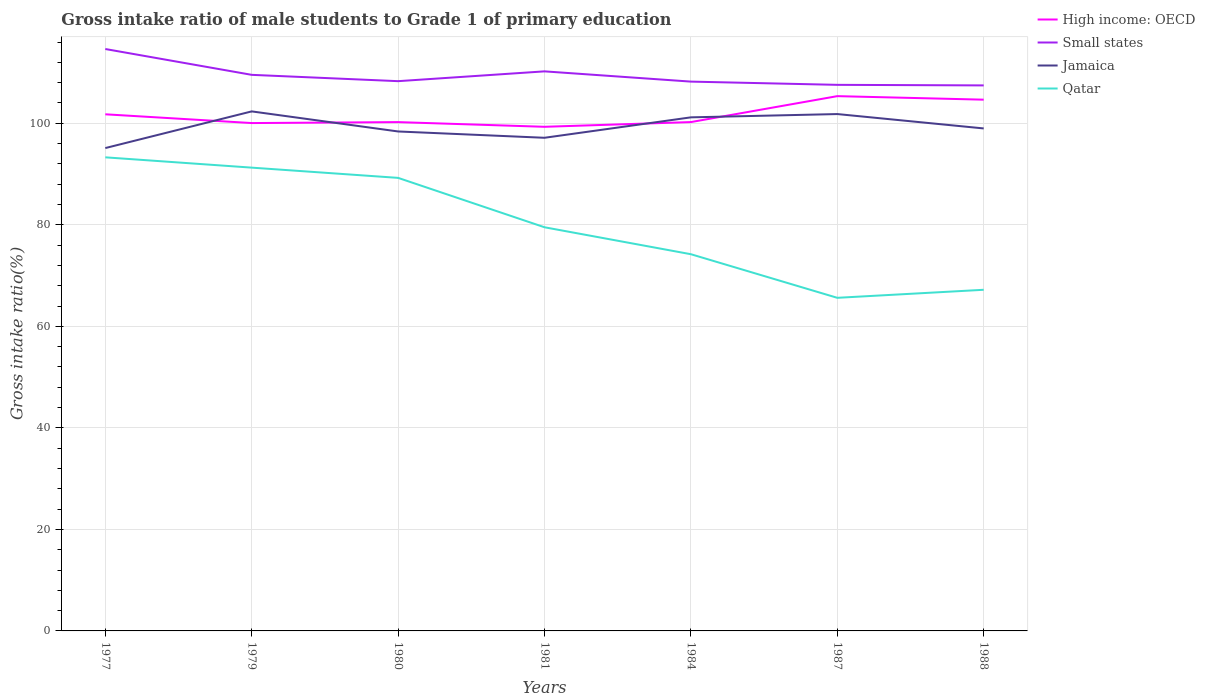How many different coloured lines are there?
Your answer should be compact. 4. Does the line corresponding to Qatar intersect with the line corresponding to High income: OECD?
Provide a short and direct response. No. Is the number of lines equal to the number of legend labels?
Make the answer very short. Yes. Across all years, what is the maximum gross intake ratio in High income: OECD?
Provide a succinct answer. 99.3. What is the total gross intake ratio in Jamaica in the graph?
Your response must be concise. -6.7. What is the difference between the highest and the second highest gross intake ratio in Jamaica?
Offer a very short reply. 7.22. What is the difference between the highest and the lowest gross intake ratio in Small states?
Your response must be concise. 3. How many years are there in the graph?
Offer a terse response. 7. What is the difference between two consecutive major ticks on the Y-axis?
Provide a short and direct response. 20. Are the values on the major ticks of Y-axis written in scientific E-notation?
Your answer should be very brief. No. Does the graph contain any zero values?
Offer a terse response. No. What is the title of the graph?
Provide a short and direct response. Gross intake ratio of male students to Grade 1 of primary education. Does "New Zealand" appear as one of the legend labels in the graph?
Offer a terse response. No. What is the label or title of the Y-axis?
Ensure brevity in your answer.  Gross intake ratio(%). What is the Gross intake ratio(%) in High income: OECD in 1977?
Offer a terse response. 101.77. What is the Gross intake ratio(%) in Small states in 1977?
Offer a terse response. 114.63. What is the Gross intake ratio(%) of Jamaica in 1977?
Give a very brief answer. 95.12. What is the Gross intake ratio(%) in Qatar in 1977?
Provide a succinct answer. 93.29. What is the Gross intake ratio(%) of High income: OECD in 1979?
Your answer should be compact. 100.04. What is the Gross intake ratio(%) in Small states in 1979?
Offer a very short reply. 109.54. What is the Gross intake ratio(%) in Jamaica in 1979?
Provide a succinct answer. 102.34. What is the Gross intake ratio(%) in Qatar in 1979?
Provide a short and direct response. 91.26. What is the Gross intake ratio(%) in High income: OECD in 1980?
Your answer should be compact. 100.23. What is the Gross intake ratio(%) in Small states in 1980?
Offer a very short reply. 108.29. What is the Gross intake ratio(%) of Jamaica in 1980?
Keep it short and to the point. 98.38. What is the Gross intake ratio(%) of Qatar in 1980?
Offer a very short reply. 89.24. What is the Gross intake ratio(%) in High income: OECD in 1981?
Provide a short and direct response. 99.3. What is the Gross intake ratio(%) in Small states in 1981?
Make the answer very short. 110.22. What is the Gross intake ratio(%) in Jamaica in 1981?
Keep it short and to the point. 97.14. What is the Gross intake ratio(%) of Qatar in 1981?
Give a very brief answer. 79.51. What is the Gross intake ratio(%) in High income: OECD in 1984?
Offer a very short reply. 100.23. What is the Gross intake ratio(%) in Small states in 1984?
Offer a very short reply. 108.2. What is the Gross intake ratio(%) of Jamaica in 1984?
Your answer should be compact. 101.17. What is the Gross intake ratio(%) of Qatar in 1984?
Ensure brevity in your answer.  74.2. What is the Gross intake ratio(%) in High income: OECD in 1987?
Keep it short and to the point. 105.34. What is the Gross intake ratio(%) of Small states in 1987?
Your response must be concise. 107.57. What is the Gross intake ratio(%) of Jamaica in 1987?
Provide a succinct answer. 101.81. What is the Gross intake ratio(%) of Qatar in 1987?
Provide a succinct answer. 65.62. What is the Gross intake ratio(%) of High income: OECD in 1988?
Your response must be concise. 104.65. What is the Gross intake ratio(%) in Small states in 1988?
Ensure brevity in your answer.  107.46. What is the Gross intake ratio(%) in Jamaica in 1988?
Your response must be concise. 98.98. What is the Gross intake ratio(%) in Qatar in 1988?
Ensure brevity in your answer.  67.2. Across all years, what is the maximum Gross intake ratio(%) of High income: OECD?
Provide a short and direct response. 105.34. Across all years, what is the maximum Gross intake ratio(%) of Small states?
Provide a succinct answer. 114.63. Across all years, what is the maximum Gross intake ratio(%) in Jamaica?
Offer a terse response. 102.34. Across all years, what is the maximum Gross intake ratio(%) of Qatar?
Your answer should be compact. 93.29. Across all years, what is the minimum Gross intake ratio(%) in High income: OECD?
Provide a short and direct response. 99.3. Across all years, what is the minimum Gross intake ratio(%) in Small states?
Your response must be concise. 107.46. Across all years, what is the minimum Gross intake ratio(%) in Jamaica?
Give a very brief answer. 95.12. Across all years, what is the minimum Gross intake ratio(%) in Qatar?
Your response must be concise. 65.62. What is the total Gross intake ratio(%) of High income: OECD in the graph?
Offer a terse response. 711.56. What is the total Gross intake ratio(%) in Small states in the graph?
Your answer should be compact. 765.91. What is the total Gross intake ratio(%) in Jamaica in the graph?
Your answer should be compact. 694.94. What is the total Gross intake ratio(%) in Qatar in the graph?
Make the answer very short. 560.32. What is the difference between the Gross intake ratio(%) of High income: OECD in 1977 and that in 1979?
Offer a very short reply. 1.73. What is the difference between the Gross intake ratio(%) in Small states in 1977 and that in 1979?
Give a very brief answer. 5.09. What is the difference between the Gross intake ratio(%) of Jamaica in 1977 and that in 1979?
Ensure brevity in your answer.  -7.22. What is the difference between the Gross intake ratio(%) of Qatar in 1977 and that in 1979?
Your answer should be compact. 2.03. What is the difference between the Gross intake ratio(%) in High income: OECD in 1977 and that in 1980?
Your answer should be very brief. 1.54. What is the difference between the Gross intake ratio(%) of Small states in 1977 and that in 1980?
Give a very brief answer. 6.33. What is the difference between the Gross intake ratio(%) in Jamaica in 1977 and that in 1980?
Offer a terse response. -3.27. What is the difference between the Gross intake ratio(%) of Qatar in 1977 and that in 1980?
Your answer should be very brief. 4.05. What is the difference between the Gross intake ratio(%) of High income: OECD in 1977 and that in 1981?
Your answer should be very brief. 2.46. What is the difference between the Gross intake ratio(%) of Small states in 1977 and that in 1981?
Ensure brevity in your answer.  4.4. What is the difference between the Gross intake ratio(%) in Jamaica in 1977 and that in 1981?
Give a very brief answer. -2.03. What is the difference between the Gross intake ratio(%) in Qatar in 1977 and that in 1981?
Make the answer very short. 13.78. What is the difference between the Gross intake ratio(%) of High income: OECD in 1977 and that in 1984?
Make the answer very short. 1.53. What is the difference between the Gross intake ratio(%) of Small states in 1977 and that in 1984?
Your answer should be compact. 6.42. What is the difference between the Gross intake ratio(%) of Jamaica in 1977 and that in 1984?
Make the answer very short. -6.05. What is the difference between the Gross intake ratio(%) in Qatar in 1977 and that in 1984?
Ensure brevity in your answer.  19.09. What is the difference between the Gross intake ratio(%) in High income: OECD in 1977 and that in 1987?
Provide a succinct answer. -3.58. What is the difference between the Gross intake ratio(%) in Small states in 1977 and that in 1987?
Ensure brevity in your answer.  7.06. What is the difference between the Gross intake ratio(%) of Jamaica in 1977 and that in 1987?
Your answer should be very brief. -6.7. What is the difference between the Gross intake ratio(%) of Qatar in 1977 and that in 1987?
Give a very brief answer. 27.67. What is the difference between the Gross intake ratio(%) of High income: OECD in 1977 and that in 1988?
Your answer should be compact. -2.88. What is the difference between the Gross intake ratio(%) in Small states in 1977 and that in 1988?
Make the answer very short. 7.17. What is the difference between the Gross intake ratio(%) in Jamaica in 1977 and that in 1988?
Provide a short and direct response. -3.87. What is the difference between the Gross intake ratio(%) in Qatar in 1977 and that in 1988?
Offer a very short reply. 26.09. What is the difference between the Gross intake ratio(%) of High income: OECD in 1979 and that in 1980?
Offer a very short reply. -0.19. What is the difference between the Gross intake ratio(%) in Small states in 1979 and that in 1980?
Your answer should be compact. 1.24. What is the difference between the Gross intake ratio(%) of Jamaica in 1979 and that in 1980?
Offer a very short reply. 3.95. What is the difference between the Gross intake ratio(%) of Qatar in 1979 and that in 1980?
Make the answer very short. 2.02. What is the difference between the Gross intake ratio(%) in High income: OECD in 1979 and that in 1981?
Make the answer very short. 0.74. What is the difference between the Gross intake ratio(%) of Small states in 1979 and that in 1981?
Your answer should be very brief. -0.69. What is the difference between the Gross intake ratio(%) of Jamaica in 1979 and that in 1981?
Your response must be concise. 5.2. What is the difference between the Gross intake ratio(%) in Qatar in 1979 and that in 1981?
Your response must be concise. 11.75. What is the difference between the Gross intake ratio(%) of High income: OECD in 1979 and that in 1984?
Offer a very short reply. -0.19. What is the difference between the Gross intake ratio(%) of Small states in 1979 and that in 1984?
Make the answer very short. 1.33. What is the difference between the Gross intake ratio(%) of Jamaica in 1979 and that in 1984?
Provide a succinct answer. 1.17. What is the difference between the Gross intake ratio(%) in Qatar in 1979 and that in 1984?
Provide a succinct answer. 17.06. What is the difference between the Gross intake ratio(%) of High income: OECD in 1979 and that in 1987?
Offer a terse response. -5.3. What is the difference between the Gross intake ratio(%) of Small states in 1979 and that in 1987?
Ensure brevity in your answer.  1.97. What is the difference between the Gross intake ratio(%) in Jamaica in 1979 and that in 1987?
Your answer should be very brief. 0.52. What is the difference between the Gross intake ratio(%) in Qatar in 1979 and that in 1987?
Ensure brevity in your answer.  25.64. What is the difference between the Gross intake ratio(%) in High income: OECD in 1979 and that in 1988?
Give a very brief answer. -4.61. What is the difference between the Gross intake ratio(%) of Small states in 1979 and that in 1988?
Provide a short and direct response. 2.08. What is the difference between the Gross intake ratio(%) of Jamaica in 1979 and that in 1988?
Keep it short and to the point. 3.36. What is the difference between the Gross intake ratio(%) of Qatar in 1979 and that in 1988?
Give a very brief answer. 24.06. What is the difference between the Gross intake ratio(%) of High income: OECD in 1980 and that in 1981?
Give a very brief answer. 0.92. What is the difference between the Gross intake ratio(%) in Small states in 1980 and that in 1981?
Your answer should be very brief. -1.93. What is the difference between the Gross intake ratio(%) of Jamaica in 1980 and that in 1981?
Your answer should be very brief. 1.24. What is the difference between the Gross intake ratio(%) of Qatar in 1980 and that in 1981?
Provide a succinct answer. 9.73. What is the difference between the Gross intake ratio(%) of High income: OECD in 1980 and that in 1984?
Provide a succinct answer. -0.01. What is the difference between the Gross intake ratio(%) of Small states in 1980 and that in 1984?
Provide a short and direct response. 0.09. What is the difference between the Gross intake ratio(%) in Jamaica in 1980 and that in 1984?
Your answer should be compact. -2.78. What is the difference between the Gross intake ratio(%) of Qatar in 1980 and that in 1984?
Ensure brevity in your answer.  15.04. What is the difference between the Gross intake ratio(%) of High income: OECD in 1980 and that in 1987?
Give a very brief answer. -5.11. What is the difference between the Gross intake ratio(%) in Small states in 1980 and that in 1987?
Keep it short and to the point. 0.72. What is the difference between the Gross intake ratio(%) of Jamaica in 1980 and that in 1987?
Your answer should be compact. -3.43. What is the difference between the Gross intake ratio(%) in Qatar in 1980 and that in 1987?
Make the answer very short. 23.63. What is the difference between the Gross intake ratio(%) of High income: OECD in 1980 and that in 1988?
Provide a short and direct response. -4.42. What is the difference between the Gross intake ratio(%) in Small states in 1980 and that in 1988?
Make the answer very short. 0.84. What is the difference between the Gross intake ratio(%) of Jamaica in 1980 and that in 1988?
Your answer should be very brief. -0.6. What is the difference between the Gross intake ratio(%) in Qatar in 1980 and that in 1988?
Your response must be concise. 22.04. What is the difference between the Gross intake ratio(%) of High income: OECD in 1981 and that in 1984?
Your answer should be compact. -0.93. What is the difference between the Gross intake ratio(%) in Small states in 1981 and that in 1984?
Your answer should be compact. 2.02. What is the difference between the Gross intake ratio(%) in Jamaica in 1981 and that in 1984?
Your answer should be very brief. -4.03. What is the difference between the Gross intake ratio(%) of Qatar in 1981 and that in 1984?
Offer a very short reply. 5.31. What is the difference between the Gross intake ratio(%) in High income: OECD in 1981 and that in 1987?
Your response must be concise. -6.04. What is the difference between the Gross intake ratio(%) in Small states in 1981 and that in 1987?
Make the answer very short. 2.66. What is the difference between the Gross intake ratio(%) of Jamaica in 1981 and that in 1987?
Give a very brief answer. -4.67. What is the difference between the Gross intake ratio(%) in Qatar in 1981 and that in 1987?
Provide a short and direct response. 13.9. What is the difference between the Gross intake ratio(%) of High income: OECD in 1981 and that in 1988?
Ensure brevity in your answer.  -5.34. What is the difference between the Gross intake ratio(%) of Small states in 1981 and that in 1988?
Make the answer very short. 2.77. What is the difference between the Gross intake ratio(%) in Jamaica in 1981 and that in 1988?
Ensure brevity in your answer.  -1.84. What is the difference between the Gross intake ratio(%) in Qatar in 1981 and that in 1988?
Make the answer very short. 12.31. What is the difference between the Gross intake ratio(%) of High income: OECD in 1984 and that in 1987?
Your answer should be compact. -5.11. What is the difference between the Gross intake ratio(%) in Small states in 1984 and that in 1987?
Ensure brevity in your answer.  0.64. What is the difference between the Gross intake ratio(%) of Jamaica in 1984 and that in 1987?
Your response must be concise. -0.65. What is the difference between the Gross intake ratio(%) of Qatar in 1984 and that in 1987?
Your response must be concise. 8.59. What is the difference between the Gross intake ratio(%) in High income: OECD in 1984 and that in 1988?
Give a very brief answer. -4.41. What is the difference between the Gross intake ratio(%) in Small states in 1984 and that in 1988?
Ensure brevity in your answer.  0.75. What is the difference between the Gross intake ratio(%) in Jamaica in 1984 and that in 1988?
Provide a succinct answer. 2.19. What is the difference between the Gross intake ratio(%) in Qatar in 1984 and that in 1988?
Ensure brevity in your answer.  7. What is the difference between the Gross intake ratio(%) of High income: OECD in 1987 and that in 1988?
Give a very brief answer. 0.7. What is the difference between the Gross intake ratio(%) in Small states in 1987 and that in 1988?
Ensure brevity in your answer.  0.11. What is the difference between the Gross intake ratio(%) of Jamaica in 1987 and that in 1988?
Provide a short and direct response. 2.83. What is the difference between the Gross intake ratio(%) of Qatar in 1987 and that in 1988?
Your answer should be compact. -1.58. What is the difference between the Gross intake ratio(%) of High income: OECD in 1977 and the Gross intake ratio(%) of Small states in 1979?
Your answer should be compact. -7.77. What is the difference between the Gross intake ratio(%) of High income: OECD in 1977 and the Gross intake ratio(%) of Jamaica in 1979?
Ensure brevity in your answer.  -0.57. What is the difference between the Gross intake ratio(%) in High income: OECD in 1977 and the Gross intake ratio(%) in Qatar in 1979?
Your answer should be very brief. 10.51. What is the difference between the Gross intake ratio(%) in Small states in 1977 and the Gross intake ratio(%) in Jamaica in 1979?
Keep it short and to the point. 12.29. What is the difference between the Gross intake ratio(%) of Small states in 1977 and the Gross intake ratio(%) of Qatar in 1979?
Your response must be concise. 23.37. What is the difference between the Gross intake ratio(%) in Jamaica in 1977 and the Gross intake ratio(%) in Qatar in 1979?
Give a very brief answer. 3.86. What is the difference between the Gross intake ratio(%) in High income: OECD in 1977 and the Gross intake ratio(%) in Small states in 1980?
Your answer should be very brief. -6.53. What is the difference between the Gross intake ratio(%) of High income: OECD in 1977 and the Gross intake ratio(%) of Jamaica in 1980?
Provide a short and direct response. 3.38. What is the difference between the Gross intake ratio(%) in High income: OECD in 1977 and the Gross intake ratio(%) in Qatar in 1980?
Give a very brief answer. 12.52. What is the difference between the Gross intake ratio(%) of Small states in 1977 and the Gross intake ratio(%) of Jamaica in 1980?
Offer a terse response. 16.24. What is the difference between the Gross intake ratio(%) of Small states in 1977 and the Gross intake ratio(%) of Qatar in 1980?
Your response must be concise. 25.38. What is the difference between the Gross intake ratio(%) of Jamaica in 1977 and the Gross intake ratio(%) of Qatar in 1980?
Make the answer very short. 5.87. What is the difference between the Gross intake ratio(%) of High income: OECD in 1977 and the Gross intake ratio(%) of Small states in 1981?
Give a very brief answer. -8.46. What is the difference between the Gross intake ratio(%) in High income: OECD in 1977 and the Gross intake ratio(%) in Jamaica in 1981?
Provide a succinct answer. 4.63. What is the difference between the Gross intake ratio(%) of High income: OECD in 1977 and the Gross intake ratio(%) of Qatar in 1981?
Provide a short and direct response. 22.25. What is the difference between the Gross intake ratio(%) of Small states in 1977 and the Gross intake ratio(%) of Jamaica in 1981?
Provide a short and direct response. 17.48. What is the difference between the Gross intake ratio(%) in Small states in 1977 and the Gross intake ratio(%) in Qatar in 1981?
Provide a succinct answer. 35.11. What is the difference between the Gross intake ratio(%) of Jamaica in 1977 and the Gross intake ratio(%) of Qatar in 1981?
Keep it short and to the point. 15.6. What is the difference between the Gross intake ratio(%) in High income: OECD in 1977 and the Gross intake ratio(%) in Small states in 1984?
Provide a succinct answer. -6.44. What is the difference between the Gross intake ratio(%) in High income: OECD in 1977 and the Gross intake ratio(%) in Jamaica in 1984?
Keep it short and to the point. 0.6. What is the difference between the Gross intake ratio(%) in High income: OECD in 1977 and the Gross intake ratio(%) in Qatar in 1984?
Offer a very short reply. 27.56. What is the difference between the Gross intake ratio(%) of Small states in 1977 and the Gross intake ratio(%) of Jamaica in 1984?
Offer a terse response. 13.46. What is the difference between the Gross intake ratio(%) in Small states in 1977 and the Gross intake ratio(%) in Qatar in 1984?
Ensure brevity in your answer.  40.42. What is the difference between the Gross intake ratio(%) of Jamaica in 1977 and the Gross intake ratio(%) of Qatar in 1984?
Offer a very short reply. 20.91. What is the difference between the Gross intake ratio(%) of High income: OECD in 1977 and the Gross intake ratio(%) of Small states in 1987?
Provide a short and direct response. -5.8. What is the difference between the Gross intake ratio(%) in High income: OECD in 1977 and the Gross intake ratio(%) in Jamaica in 1987?
Give a very brief answer. -0.05. What is the difference between the Gross intake ratio(%) of High income: OECD in 1977 and the Gross intake ratio(%) of Qatar in 1987?
Your response must be concise. 36.15. What is the difference between the Gross intake ratio(%) of Small states in 1977 and the Gross intake ratio(%) of Jamaica in 1987?
Make the answer very short. 12.81. What is the difference between the Gross intake ratio(%) of Small states in 1977 and the Gross intake ratio(%) of Qatar in 1987?
Your answer should be compact. 49.01. What is the difference between the Gross intake ratio(%) of Jamaica in 1977 and the Gross intake ratio(%) of Qatar in 1987?
Ensure brevity in your answer.  29.5. What is the difference between the Gross intake ratio(%) in High income: OECD in 1977 and the Gross intake ratio(%) in Small states in 1988?
Provide a short and direct response. -5.69. What is the difference between the Gross intake ratio(%) in High income: OECD in 1977 and the Gross intake ratio(%) in Jamaica in 1988?
Your answer should be very brief. 2.79. What is the difference between the Gross intake ratio(%) in High income: OECD in 1977 and the Gross intake ratio(%) in Qatar in 1988?
Ensure brevity in your answer.  34.57. What is the difference between the Gross intake ratio(%) of Small states in 1977 and the Gross intake ratio(%) of Jamaica in 1988?
Keep it short and to the point. 15.64. What is the difference between the Gross intake ratio(%) of Small states in 1977 and the Gross intake ratio(%) of Qatar in 1988?
Provide a succinct answer. 47.43. What is the difference between the Gross intake ratio(%) of Jamaica in 1977 and the Gross intake ratio(%) of Qatar in 1988?
Provide a succinct answer. 27.92. What is the difference between the Gross intake ratio(%) in High income: OECD in 1979 and the Gross intake ratio(%) in Small states in 1980?
Your response must be concise. -8.25. What is the difference between the Gross intake ratio(%) of High income: OECD in 1979 and the Gross intake ratio(%) of Jamaica in 1980?
Make the answer very short. 1.66. What is the difference between the Gross intake ratio(%) of High income: OECD in 1979 and the Gross intake ratio(%) of Qatar in 1980?
Offer a terse response. 10.8. What is the difference between the Gross intake ratio(%) of Small states in 1979 and the Gross intake ratio(%) of Jamaica in 1980?
Provide a short and direct response. 11.15. What is the difference between the Gross intake ratio(%) of Small states in 1979 and the Gross intake ratio(%) of Qatar in 1980?
Offer a terse response. 20.29. What is the difference between the Gross intake ratio(%) in Jamaica in 1979 and the Gross intake ratio(%) in Qatar in 1980?
Ensure brevity in your answer.  13.09. What is the difference between the Gross intake ratio(%) in High income: OECD in 1979 and the Gross intake ratio(%) in Small states in 1981?
Your response must be concise. -10.18. What is the difference between the Gross intake ratio(%) of High income: OECD in 1979 and the Gross intake ratio(%) of Jamaica in 1981?
Your answer should be compact. 2.9. What is the difference between the Gross intake ratio(%) of High income: OECD in 1979 and the Gross intake ratio(%) of Qatar in 1981?
Offer a terse response. 20.53. What is the difference between the Gross intake ratio(%) in Small states in 1979 and the Gross intake ratio(%) in Jamaica in 1981?
Ensure brevity in your answer.  12.4. What is the difference between the Gross intake ratio(%) of Small states in 1979 and the Gross intake ratio(%) of Qatar in 1981?
Make the answer very short. 30.02. What is the difference between the Gross intake ratio(%) of Jamaica in 1979 and the Gross intake ratio(%) of Qatar in 1981?
Give a very brief answer. 22.82. What is the difference between the Gross intake ratio(%) of High income: OECD in 1979 and the Gross intake ratio(%) of Small states in 1984?
Your answer should be very brief. -8.16. What is the difference between the Gross intake ratio(%) in High income: OECD in 1979 and the Gross intake ratio(%) in Jamaica in 1984?
Provide a succinct answer. -1.13. What is the difference between the Gross intake ratio(%) of High income: OECD in 1979 and the Gross intake ratio(%) of Qatar in 1984?
Ensure brevity in your answer.  25.84. What is the difference between the Gross intake ratio(%) in Small states in 1979 and the Gross intake ratio(%) in Jamaica in 1984?
Give a very brief answer. 8.37. What is the difference between the Gross intake ratio(%) of Small states in 1979 and the Gross intake ratio(%) of Qatar in 1984?
Your answer should be compact. 35.33. What is the difference between the Gross intake ratio(%) of Jamaica in 1979 and the Gross intake ratio(%) of Qatar in 1984?
Keep it short and to the point. 28.13. What is the difference between the Gross intake ratio(%) in High income: OECD in 1979 and the Gross intake ratio(%) in Small states in 1987?
Ensure brevity in your answer.  -7.53. What is the difference between the Gross intake ratio(%) in High income: OECD in 1979 and the Gross intake ratio(%) in Jamaica in 1987?
Ensure brevity in your answer.  -1.77. What is the difference between the Gross intake ratio(%) of High income: OECD in 1979 and the Gross intake ratio(%) of Qatar in 1987?
Your answer should be compact. 34.42. What is the difference between the Gross intake ratio(%) in Small states in 1979 and the Gross intake ratio(%) in Jamaica in 1987?
Ensure brevity in your answer.  7.72. What is the difference between the Gross intake ratio(%) in Small states in 1979 and the Gross intake ratio(%) in Qatar in 1987?
Provide a short and direct response. 43.92. What is the difference between the Gross intake ratio(%) of Jamaica in 1979 and the Gross intake ratio(%) of Qatar in 1987?
Your answer should be compact. 36.72. What is the difference between the Gross intake ratio(%) in High income: OECD in 1979 and the Gross intake ratio(%) in Small states in 1988?
Your response must be concise. -7.42. What is the difference between the Gross intake ratio(%) in High income: OECD in 1979 and the Gross intake ratio(%) in Jamaica in 1988?
Ensure brevity in your answer.  1.06. What is the difference between the Gross intake ratio(%) in High income: OECD in 1979 and the Gross intake ratio(%) in Qatar in 1988?
Provide a succinct answer. 32.84. What is the difference between the Gross intake ratio(%) of Small states in 1979 and the Gross intake ratio(%) of Jamaica in 1988?
Offer a very short reply. 10.56. What is the difference between the Gross intake ratio(%) of Small states in 1979 and the Gross intake ratio(%) of Qatar in 1988?
Provide a succinct answer. 42.34. What is the difference between the Gross intake ratio(%) of Jamaica in 1979 and the Gross intake ratio(%) of Qatar in 1988?
Give a very brief answer. 35.14. What is the difference between the Gross intake ratio(%) of High income: OECD in 1980 and the Gross intake ratio(%) of Small states in 1981?
Ensure brevity in your answer.  -10. What is the difference between the Gross intake ratio(%) of High income: OECD in 1980 and the Gross intake ratio(%) of Jamaica in 1981?
Offer a terse response. 3.09. What is the difference between the Gross intake ratio(%) in High income: OECD in 1980 and the Gross intake ratio(%) in Qatar in 1981?
Provide a short and direct response. 20.71. What is the difference between the Gross intake ratio(%) of Small states in 1980 and the Gross intake ratio(%) of Jamaica in 1981?
Offer a very short reply. 11.15. What is the difference between the Gross intake ratio(%) in Small states in 1980 and the Gross intake ratio(%) in Qatar in 1981?
Give a very brief answer. 28.78. What is the difference between the Gross intake ratio(%) of Jamaica in 1980 and the Gross intake ratio(%) of Qatar in 1981?
Give a very brief answer. 18.87. What is the difference between the Gross intake ratio(%) of High income: OECD in 1980 and the Gross intake ratio(%) of Small states in 1984?
Your response must be concise. -7.98. What is the difference between the Gross intake ratio(%) of High income: OECD in 1980 and the Gross intake ratio(%) of Jamaica in 1984?
Make the answer very short. -0.94. What is the difference between the Gross intake ratio(%) in High income: OECD in 1980 and the Gross intake ratio(%) in Qatar in 1984?
Your answer should be very brief. 26.02. What is the difference between the Gross intake ratio(%) in Small states in 1980 and the Gross intake ratio(%) in Jamaica in 1984?
Provide a succinct answer. 7.13. What is the difference between the Gross intake ratio(%) in Small states in 1980 and the Gross intake ratio(%) in Qatar in 1984?
Your answer should be very brief. 34.09. What is the difference between the Gross intake ratio(%) of Jamaica in 1980 and the Gross intake ratio(%) of Qatar in 1984?
Your response must be concise. 24.18. What is the difference between the Gross intake ratio(%) of High income: OECD in 1980 and the Gross intake ratio(%) of Small states in 1987?
Offer a very short reply. -7.34. What is the difference between the Gross intake ratio(%) in High income: OECD in 1980 and the Gross intake ratio(%) in Jamaica in 1987?
Offer a terse response. -1.59. What is the difference between the Gross intake ratio(%) of High income: OECD in 1980 and the Gross intake ratio(%) of Qatar in 1987?
Provide a succinct answer. 34.61. What is the difference between the Gross intake ratio(%) in Small states in 1980 and the Gross intake ratio(%) in Jamaica in 1987?
Give a very brief answer. 6.48. What is the difference between the Gross intake ratio(%) of Small states in 1980 and the Gross intake ratio(%) of Qatar in 1987?
Your answer should be very brief. 42.68. What is the difference between the Gross intake ratio(%) in Jamaica in 1980 and the Gross intake ratio(%) in Qatar in 1987?
Your answer should be compact. 32.77. What is the difference between the Gross intake ratio(%) of High income: OECD in 1980 and the Gross intake ratio(%) of Small states in 1988?
Provide a short and direct response. -7.23. What is the difference between the Gross intake ratio(%) of High income: OECD in 1980 and the Gross intake ratio(%) of Jamaica in 1988?
Offer a very short reply. 1.25. What is the difference between the Gross intake ratio(%) in High income: OECD in 1980 and the Gross intake ratio(%) in Qatar in 1988?
Your answer should be very brief. 33.03. What is the difference between the Gross intake ratio(%) in Small states in 1980 and the Gross intake ratio(%) in Jamaica in 1988?
Offer a terse response. 9.31. What is the difference between the Gross intake ratio(%) of Small states in 1980 and the Gross intake ratio(%) of Qatar in 1988?
Make the answer very short. 41.09. What is the difference between the Gross intake ratio(%) in Jamaica in 1980 and the Gross intake ratio(%) in Qatar in 1988?
Your answer should be very brief. 31.18. What is the difference between the Gross intake ratio(%) of High income: OECD in 1981 and the Gross intake ratio(%) of Small states in 1984?
Provide a succinct answer. -8.9. What is the difference between the Gross intake ratio(%) in High income: OECD in 1981 and the Gross intake ratio(%) in Jamaica in 1984?
Your answer should be very brief. -1.86. What is the difference between the Gross intake ratio(%) of High income: OECD in 1981 and the Gross intake ratio(%) of Qatar in 1984?
Give a very brief answer. 25.1. What is the difference between the Gross intake ratio(%) in Small states in 1981 and the Gross intake ratio(%) in Jamaica in 1984?
Your answer should be very brief. 9.06. What is the difference between the Gross intake ratio(%) in Small states in 1981 and the Gross intake ratio(%) in Qatar in 1984?
Offer a very short reply. 36.02. What is the difference between the Gross intake ratio(%) of Jamaica in 1981 and the Gross intake ratio(%) of Qatar in 1984?
Keep it short and to the point. 22.94. What is the difference between the Gross intake ratio(%) of High income: OECD in 1981 and the Gross intake ratio(%) of Small states in 1987?
Give a very brief answer. -8.26. What is the difference between the Gross intake ratio(%) of High income: OECD in 1981 and the Gross intake ratio(%) of Jamaica in 1987?
Ensure brevity in your answer.  -2.51. What is the difference between the Gross intake ratio(%) of High income: OECD in 1981 and the Gross intake ratio(%) of Qatar in 1987?
Provide a short and direct response. 33.69. What is the difference between the Gross intake ratio(%) of Small states in 1981 and the Gross intake ratio(%) of Jamaica in 1987?
Ensure brevity in your answer.  8.41. What is the difference between the Gross intake ratio(%) of Small states in 1981 and the Gross intake ratio(%) of Qatar in 1987?
Ensure brevity in your answer.  44.61. What is the difference between the Gross intake ratio(%) in Jamaica in 1981 and the Gross intake ratio(%) in Qatar in 1987?
Provide a succinct answer. 31.52. What is the difference between the Gross intake ratio(%) in High income: OECD in 1981 and the Gross intake ratio(%) in Small states in 1988?
Offer a very short reply. -8.15. What is the difference between the Gross intake ratio(%) of High income: OECD in 1981 and the Gross intake ratio(%) of Jamaica in 1988?
Provide a succinct answer. 0.32. What is the difference between the Gross intake ratio(%) in High income: OECD in 1981 and the Gross intake ratio(%) in Qatar in 1988?
Keep it short and to the point. 32.1. What is the difference between the Gross intake ratio(%) in Small states in 1981 and the Gross intake ratio(%) in Jamaica in 1988?
Make the answer very short. 11.24. What is the difference between the Gross intake ratio(%) in Small states in 1981 and the Gross intake ratio(%) in Qatar in 1988?
Give a very brief answer. 43.02. What is the difference between the Gross intake ratio(%) of Jamaica in 1981 and the Gross intake ratio(%) of Qatar in 1988?
Provide a succinct answer. 29.94. What is the difference between the Gross intake ratio(%) of High income: OECD in 1984 and the Gross intake ratio(%) of Small states in 1987?
Make the answer very short. -7.33. What is the difference between the Gross intake ratio(%) of High income: OECD in 1984 and the Gross intake ratio(%) of Jamaica in 1987?
Provide a short and direct response. -1.58. What is the difference between the Gross intake ratio(%) in High income: OECD in 1984 and the Gross intake ratio(%) in Qatar in 1987?
Make the answer very short. 34.62. What is the difference between the Gross intake ratio(%) of Small states in 1984 and the Gross intake ratio(%) of Jamaica in 1987?
Ensure brevity in your answer.  6.39. What is the difference between the Gross intake ratio(%) of Small states in 1984 and the Gross intake ratio(%) of Qatar in 1987?
Keep it short and to the point. 42.59. What is the difference between the Gross intake ratio(%) in Jamaica in 1984 and the Gross intake ratio(%) in Qatar in 1987?
Provide a succinct answer. 35.55. What is the difference between the Gross intake ratio(%) of High income: OECD in 1984 and the Gross intake ratio(%) of Small states in 1988?
Your response must be concise. -7.22. What is the difference between the Gross intake ratio(%) in High income: OECD in 1984 and the Gross intake ratio(%) in Jamaica in 1988?
Offer a terse response. 1.25. What is the difference between the Gross intake ratio(%) in High income: OECD in 1984 and the Gross intake ratio(%) in Qatar in 1988?
Your answer should be very brief. 33.03. What is the difference between the Gross intake ratio(%) of Small states in 1984 and the Gross intake ratio(%) of Jamaica in 1988?
Provide a short and direct response. 9.22. What is the difference between the Gross intake ratio(%) of Small states in 1984 and the Gross intake ratio(%) of Qatar in 1988?
Provide a short and direct response. 41. What is the difference between the Gross intake ratio(%) of Jamaica in 1984 and the Gross intake ratio(%) of Qatar in 1988?
Ensure brevity in your answer.  33.97. What is the difference between the Gross intake ratio(%) of High income: OECD in 1987 and the Gross intake ratio(%) of Small states in 1988?
Make the answer very short. -2.11. What is the difference between the Gross intake ratio(%) in High income: OECD in 1987 and the Gross intake ratio(%) in Jamaica in 1988?
Offer a terse response. 6.36. What is the difference between the Gross intake ratio(%) in High income: OECD in 1987 and the Gross intake ratio(%) in Qatar in 1988?
Your answer should be very brief. 38.14. What is the difference between the Gross intake ratio(%) of Small states in 1987 and the Gross intake ratio(%) of Jamaica in 1988?
Provide a short and direct response. 8.59. What is the difference between the Gross intake ratio(%) in Small states in 1987 and the Gross intake ratio(%) in Qatar in 1988?
Your answer should be compact. 40.37. What is the difference between the Gross intake ratio(%) in Jamaica in 1987 and the Gross intake ratio(%) in Qatar in 1988?
Ensure brevity in your answer.  34.61. What is the average Gross intake ratio(%) of High income: OECD per year?
Your response must be concise. 101.65. What is the average Gross intake ratio(%) of Small states per year?
Your response must be concise. 109.42. What is the average Gross intake ratio(%) in Jamaica per year?
Make the answer very short. 99.28. What is the average Gross intake ratio(%) of Qatar per year?
Keep it short and to the point. 80.05. In the year 1977, what is the difference between the Gross intake ratio(%) in High income: OECD and Gross intake ratio(%) in Small states?
Your response must be concise. -12.86. In the year 1977, what is the difference between the Gross intake ratio(%) of High income: OECD and Gross intake ratio(%) of Jamaica?
Give a very brief answer. 6.65. In the year 1977, what is the difference between the Gross intake ratio(%) of High income: OECD and Gross intake ratio(%) of Qatar?
Your answer should be very brief. 8.48. In the year 1977, what is the difference between the Gross intake ratio(%) of Small states and Gross intake ratio(%) of Jamaica?
Give a very brief answer. 19.51. In the year 1977, what is the difference between the Gross intake ratio(%) of Small states and Gross intake ratio(%) of Qatar?
Your answer should be compact. 21.34. In the year 1977, what is the difference between the Gross intake ratio(%) in Jamaica and Gross intake ratio(%) in Qatar?
Offer a very short reply. 1.83. In the year 1979, what is the difference between the Gross intake ratio(%) in High income: OECD and Gross intake ratio(%) in Small states?
Offer a very short reply. -9.5. In the year 1979, what is the difference between the Gross intake ratio(%) of High income: OECD and Gross intake ratio(%) of Jamaica?
Offer a very short reply. -2.3. In the year 1979, what is the difference between the Gross intake ratio(%) of High income: OECD and Gross intake ratio(%) of Qatar?
Make the answer very short. 8.78. In the year 1979, what is the difference between the Gross intake ratio(%) in Small states and Gross intake ratio(%) in Jamaica?
Your response must be concise. 7.2. In the year 1979, what is the difference between the Gross intake ratio(%) in Small states and Gross intake ratio(%) in Qatar?
Give a very brief answer. 18.28. In the year 1979, what is the difference between the Gross intake ratio(%) of Jamaica and Gross intake ratio(%) of Qatar?
Offer a very short reply. 11.08. In the year 1980, what is the difference between the Gross intake ratio(%) in High income: OECD and Gross intake ratio(%) in Small states?
Give a very brief answer. -8.06. In the year 1980, what is the difference between the Gross intake ratio(%) of High income: OECD and Gross intake ratio(%) of Jamaica?
Make the answer very short. 1.84. In the year 1980, what is the difference between the Gross intake ratio(%) of High income: OECD and Gross intake ratio(%) of Qatar?
Provide a short and direct response. 10.99. In the year 1980, what is the difference between the Gross intake ratio(%) of Small states and Gross intake ratio(%) of Jamaica?
Your answer should be compact. 9.91. In the year 1980, what is the difference between the Gross intake ratio(%) of Small states and Gross intake ratio(%) of Qatar?
Keep it short and to the point. 19.05. In the year 1980, what is the difference between the Gross intake ratio(%) in Jamaica and Gross intake ratio(%) in Qatar?
Offer a terse response. 9.14. In the year 1981, what is the difference between the Gross intake ratio(%) of High income: OECD and Gross intake ratio(%) of Small states?
Ensure brevity in your answer.  -10.92. In the year 1981, what is the difference between the Gross intake ratio(%) of High income: OECD and Gross intake ratio(%) of Jamaica?
Make the answer very short. 2.16. In the year 1981, what is the difference between the Gross intake ratio(%) in High income: OECD and Gross intake ratio(%) in Qatar?
Provide a succinct answer. 19.79. In the year 1981, what is the difference between the Gross intake ratio(%) of Small states and Gross intake ratio(%) of Jamaica?
Provide a short and direct response. 13.08. In the year 1981, what is the difference between the Gross intake ratio(%) of Small states and Gross intake ratio(%) of Qatar?
Give a very brief answer. 30.71. In the year 1981, what is the difference between the Gross intake ratio(%) in Jamaica and Gross intake ratio(%) in Qatar?
Your answer should be very brief. 17.63. In the year 1984, what is the difference between the Gross intake ratio(%) in High income: OECD and Gross intake ratio(%) in Small states?
Your response must be concise. -7.97. In the year 1984, what is the difference between the Gross intake ratio(%) of High income: OECD and Gross intake ratio(%) of Jamaica?
Your answer should be very brief. -0.93. In the year 1984, what is the difference between the Gross intake ratio(%) in High income: OECD and Gross intake ratio(%) in Qatar?
Make the answer very short. 26.03. In the year 1984, what is the difference between the Gross intake ratio(%) in Small states and Gross intake ratio(%) in Jamaica?
Your answer should be compact. 7.04. In the year 1984, what is the difference between the Gross intake ratio(%) in Small states and Gross intake ratio(%) in Qatar?
Your response must be concise. 34. In the year 1984, what is the difference between the Gross intake ratio(%) in Jamaica and Gross intake ratio(%) in Qatar?
Make the answer very short. 26.96. In the year 1987, what is the difference between the Gross intake ratio(%) of High income: OECD and Gross intake ratio(%) of Small states?
Provide a short and direct response. -2.23. In the year 1987, what is the difference between the Gross intake ratio(%) in High income: OECD and Gross intake ratio(%) in Jamaica?
Provide a short and direct response. 3.53. In the year 1987, what is the difference between the Gross intake ratio(%) of High income: OECD and Gross intake ratio(%) of Qatar?
Your answer should be compact. 39.73. In the year 1987, what is the difference between the Gross intake ratio(%) of Small states and Gross intake ratio(%) of Jamaica?
Give a very brief answer. 5.75. In the year 1987, what is the difference between the Gross intake ratio(%) in Small states and Gross intake ratio(%) in Qatar?
Keep it short and to the point. 41.95. In the year 1987, what is the difference between the Gross intake ratio(%) of Jamaica and Gross intake ratio(%) of Qatar?
Your answer should be very brief. 36.2. In the year 1988, what is the difference between the Gross intake ratio(%) of High income: OECD and Gross intake ratio(%) of Small states?
Make the answer very short. -2.81. In the year 1988, what is the difference between the Gross intake ratio(%) of High income: OECD and Gross intake ratio(%) of Jamaica?
Offer a terse response. 5.67. In the year 1988, what is the difference between the Gross intake ratio(%) in High income: OECD and Gross intake ratio(%) in Qatar?
Ensure brevity in your answer.  37.45. In the year 1988, what is the difference between the Gross intake ratio(%) in Small states and Gross intake ratio(%) in Jamaica?
Make the answer very short. 8.48. In the year 1988, what is the difference between the Gross intake ratio(%) of Small states and Gross intake ratio(%) of Qatar?
Make the answer very short. 40.26. In the year 1988, what is the difference between the Gross intake ratio(%) in Jamaica and Gross intake ratio(%) in Qatar?
Provide a short and direct response. 31.78. What is the ratio of the Gross intake ratio(%) of High income: OECD in 1977 to that in 1979?
Ensure brevity in your answer.  1.02. What is the ratio of the Gross intake ratio(%) of Small states in 1977 to that in 1979?
Give a very brief answer. 1.05. What is the ratio of the Gross intake ratio(%) of Jamaica in 1977 to that in 1979?
Your response must be concise. 0.93. What is the ratio of the Gross intake ratio(%) of Qatar in 1977 to that in 1979?
Provide a succinct answer. 1.02. What is the ratio of the Gross intake ratio(%) of High income: OECD in 1977 to that in 1980?
Keep it short and to the point. 1.02. What is the ratio of the Gross intake ratio(%) of Small states in 1977 to that in 1980?
Your answer should be very brief. 1.06. What is the ratio of the Gross intake ratio(%) of Jamaica in 1977 to that in 1980?
Your response must be concise. 0.97. What is the ratio of the Gross intake ratio(%) of Qatar in 1977 to that in 1980?
Provide a succinct answer. 1.05. What is the ratio of the Gross intake ratio(%) in High income: OECD in 1977 to that in 1981?
Make the answer very short. 1.02. What is the ratio of the Gross intake ratio(%) of Small states in 1977 to that in 1981?
Your answer should be very brief. 1.04. What is the ratio of the Gross intake ratio(%) in Jamaica in 1977 to that in 1981?
Offer a very short reply. 0.98. What is the ratio of the Gross intake ratio(%) in Qatar in 1977 to that in 1981?
Offer a very short reply. 1.17. What is the ratio of the Gross intake ratio(%) in High income: OECD in 1977 to that in 1984?
Your answer should be very brief. 1.02. What is the ratio of the Gross intake ratio(%) of Small states in 1977 to that in 1984?
Give a very brief answer. 1.06. What is the ratio of the Gross intake ratio(%) in Jamaica in 1977 to that in 1984?
Provide a succinct answer. 0.94. What is the ratio of the Gross intake ratio(%) in Qatar in 1977 to that in 1984?
Your response must be concise. 1.26. What is the ratio of the Gross intake ratio(%) in High income: OECD in 1977 to that in 1987?
Provide a short and direct response. 0.97. What is the ratio of the Gross intake ratio(%) in Small states in 1977 to that in 1987?
Provide a succinct answer. 1.07. What is the ratio of the Gross intake ratio(%) of Jamaica in 1977 to that in 1987?
Your answer should be compact. 0.93. What is the ratio of the Gross intake ratio(%) of Qatar in 1977 to that in 1987?
Keep it short and to the point. 1.42. What is the ratio of the Gross intake ratio(%) in High income: OECD in 1977 to that in 1988?
Give a very brief answer. 0.97. What is the ratio of the Gross intake ratio(%) of Small states in 1977 to that in 1988?
Give a very brief answer. 1.07. What is the ratio of the Gross intake ratio(%) of Jamaica in 1977 to that in 1988?
Make the answer very short. 0.96. What is the ratio of the Gross intake ratio(%) of Qatar in 1977 to that in 1988?
Offer a terse response. 1.39. What is the ratio of the Gross intake ratio(%) of Small states in 1979 to that in 1980?
Provide a short and direct response. 1.01. What is the ratio of the Gross intake ratio(%) in Jamaica in 1979 to that in 1980?
Make the answer very short. 1.04. What is the ratio of the Gross intake ratio(%) in Qatar in 1979 to that in 1980?
Keep it short and to the point. 1.02. What is the ratio of the Gross intake ratio(%) of High income: OECD in 1979 to that in 1981?
Provide a succinct answer. 1.01. What is the ratio of the Gross intake ratio(%) of Jamaica in 1979 to that in 1981?
Provide a succinct answer. 1.05. What is the ratio of the Gross intake ratio(%) of Qatar in 1979 to that in 1981?
Your response must be concise. 1.15. What is the ratio of the Gross intake ratio(%) of High income: OECD in 1979 to that in 1984?
Provide a succinct answer. 1. What is the ratio of the Gross intake ratio(%) of Small states in 1979 to that in 1984?
Offer a very short reply. 1.01. What is the ratio of the Gross intake ratio(%) of Jamaica in 1979 to that in 1984?
Give a very brief answer. 1.01. What is the ratio of the Gross intake ratio(%) of Qatar in 1979 to that in 1984?
Offer a terse response. 1.23. What is the ratio of the Gross intake ratio(%) of High income: OECD in 1979 to that in 1987?
Your response must be concise. 0.95. What is the ratio of the Gross intake ratio(%) in Small states in 1979 to that in 1987?
Provide a succinct answer. 1.02. What is the ratio of the Gross intake ratio(%) of Jamaica in 1979 to that in 1987?
Provide a short and direct response. 1.01. What is the ratio of the Gross intake ratio(%) of Qatar in 1979 to that in 1987?
Your answer should be compact. 1.39. What is the ratio of the Gross intake ratio(%) of High income: OECD in 1979 to that in 1988?
Provide a succinct answer. 0.96. What is the ratio of the Gross intake ratio(%) of Small states in 1979 to that in 1988?
Provide a short and direct response. 1.02. What is the ratio of the Gross intake ratio(%) of Jamaica in 1979 to that in 1988?
Your response must be concise. 1.03. What is the ratio of the Gross intake ratio(%) of Qatar in 1979 to that in 1988?
Your answer should be compact. 1.36. What is the ratio of the Gross intake ratio(%) of High income: OECD in 1980 to that in 1981?
Your answer should be very brief. 1.01. What is the ratio of the Gross intake ratio(%) of Small states in 1980 to that in 1981?
Offer a very short reply. 0.98. What is the ratio of the Gross intake ratio(%) of Jamaica in 1980 to that in 1981?
Make the answer very short. 1.01. What is the ratio of the Gross intake ratio(%) in Qatar in 1980 to that in 1981?
Give a very brief answer. 1.12. What is the ratio of the Gross intake ratio(%) of Small states in 1980 to that in 1984?
Offer a very short reply. 1. What is the ratio of the Gross intake ratio(%) in Jamaica in 1980 to that in 1984?
Give a very brief answer. 0.97. What is the ratio of the Gross intake ratio(%) of Qatar in 1980 to that in 1984?
Ensure brevity in your answer.  1.2. What is the ratio of the Gross intake ratio(%) in High income: OECD in 1980 to that in 1987?
Ensure brevity in your answer.  0.95. What is the ratio of the Gross intake ratio(%) in Small states in 1980 to that in 1987?
Your answer should be very brief. 1.01. What is the ratio of the Gross intake ratio(%) in Jamaica in 1980 to that in 1987?
Ensure brevity in your answer.  0.97. What is the ratio of the Gross intake ratio(%) in Qatar in 1980 to that in 1987?
Give a very brief answer. 1.36. What is the ratio of the Gross intake ratio(%) in High income: OECD in 1980 to that in 1988?
Provide a short and direct response. 0.96. What is the ratio of the Gross intake ratio(%) in Qatar in 1980 to that in 1988?
Ensure brevity in your answer.  1.33. What is the ratio of the Gross intake ratio(%) of High income: OECD in 1981 to that in 1984?
Your answer should be very brief. 0.99. What is the ratio of the Gross intake ratio(%) in Small states in 1981 to that in 1984?
Provide a succinct answer. 1.02. What is the ratio of the Gross intake ratio(%) of Jamaica in 1981 to that in 1984?
Your answer should be very brief. 0.96. What is the ratio of the Gross intake ratio(%) of Qatar in 1981 to that in 1984?
Provide a short and direct response. 1.07. What is the ratio of the Gross intake ratio(%) of High income: OECD in 1981 to that in 1987?
Offer a terse response. 0.94. What is the ratio of the Gross intake ratio(%) of Small states in 1981 to that in 1987?
Your answer should be compact. 1.02. What is the ratio of the Gross intake ratio(%) of Jamaica in 1981 to that in 1987?
Keep it short and to the point. 0.95. What is the ratio of the Gross intake ratio(%) of Qatar in 1981 to that in 1987?
Provide a short and direct response. 1.21. What is the ratio of the Gross intake ratio(%) in High income: OECD in 1981 to that in 1988?
Make the answer very short. 0.95. What is the ratio of the Gross intake ratio(%) in Small states in 1981 to that in 1988?
Your response must be concise. 1.03. What is the ratio of the Gross intake ratio(%) in Jamaica in 1981 to that in 1988?
Your answer should be very brief. 0.98. What is the ratio of the Gross intake ratio(%) in Qatar in 1981 to that in 1988?
Your answer should be compact. 1.18. What is the ratio of the Gross intake ratio(%) of High income: OECD in 1984 to that in 1987?
Your response must be concise. 0.95. What is the ratio of the Gross intake ratio(%) in Small states in 1984 to that in 1987?
Offer a terse response. 1.01. What is the ratio of the Gross intake ratio(%) in Jamaica in 1984 to that in 1987?
Make the answer very short. 0.99. What is the ratio of the Gross intake ratio(%) in Qatar in 1984 to that in 1987?
Keep it short and to the point. 1.13. What is the ratio of the Gross intake ratio(%) of High income: OECD in 1984 to that in 1988?
Offer a terse response. 0.96. What is the ratio of the Gross intake ratio(%) of Small states in 1984 to that in 1988?
Offer a terse response. 1.01. What is the ratio of the Gross intake ratio(%) of Jamaica in 1984 to that in 1988?
Offer a terse response. 1.02. What is the ratio of the Gross intake ratio(%) of Qatar in 1984 to that in 1988?
Your answer should be compact. 1.1. What is the ratio of the Gross intake ratio(%) of High income: OECD in 1987 to that in 1988?
Offer a terse response. 1.01. What is the ratio of the Gross intake ratio(%) in Small states in 1987 to that in 1988?
Provide a short and direct response. 1. What is the ratio of the Gross intake ratio(%) of Jamaica in 1987 to that in 1988?
Your answer should be very brief. 1.03. What is the ratio of the Gross intake ratio(%) of Qatar in 1987 to that in 1988?
Provide a succinct answer. 0.98. What is the difference between the highest and the second highest Gross intake ratio(%) of High income: OECD?
Your answer should be compact. 0.7. What is the difference between the highest and the second highest Gross intake ratio(%) of Small states?
Make the answer very short. 4.4. What is the difference between the highest and the second highest Gross intake ratio(%) in Jamaica?
Provide a succinct answer. 0.52. What is the difference between the highest and the second highest Gross intake ratio(%) in Qatar?
Give a very brief answer. 2.03. What is the difference between the highest and the lowest Gross intake ratio(%) of High income: OECD?
Your answer should be very brief. 6.04. What is the difference between the highest and the lowest Gross intake ratio(%) of Small states?
Give a very brief answer. 7.17. What is the difference between the highest and the lowest Gross intake ratio(%) in Jamaica?
Offer a terse response. 7.22. What is the difference between the highest and the lowest Gross intake ratio(%) of Qatar?
Ensure brevity in your answer.  27.67. 